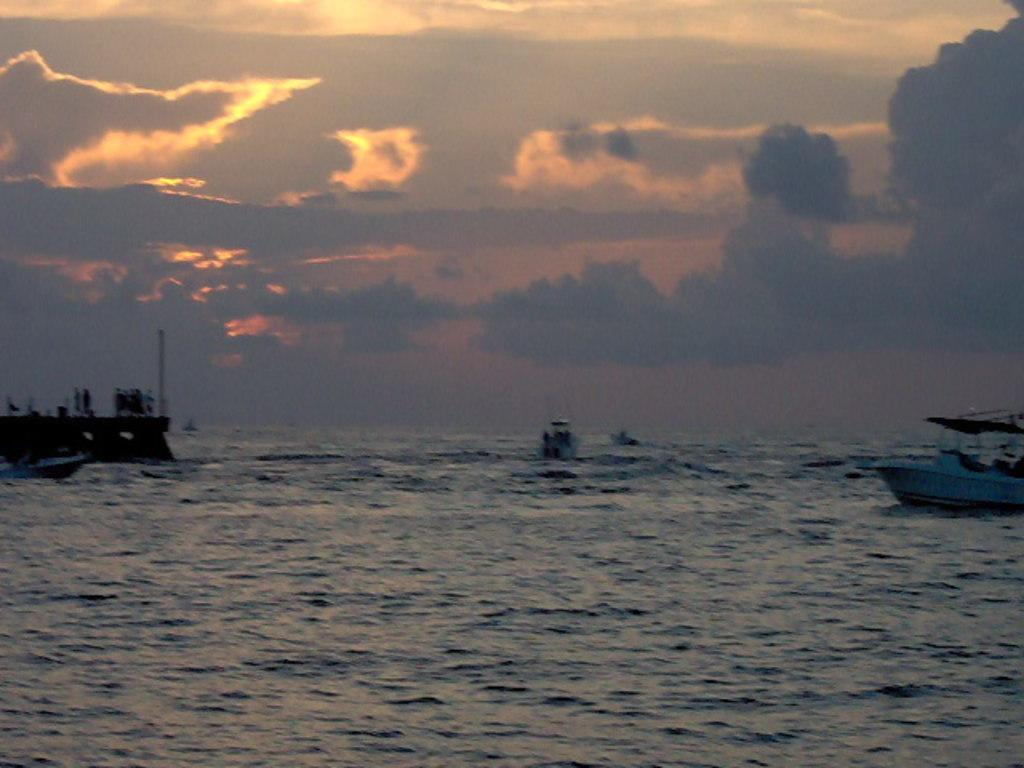What type of vehicles are in the image? There are boats in the image. Where are the boats located? The boats are on the water. What type of water body are the boats on? The water is part of an ocean. What can be seen in the sky in the background of the image? There are clouds in the sky in the background of the image. What color is the ink used to write the boats' names in the image? There is no ink or writing present in the image; it features boats on the water. 